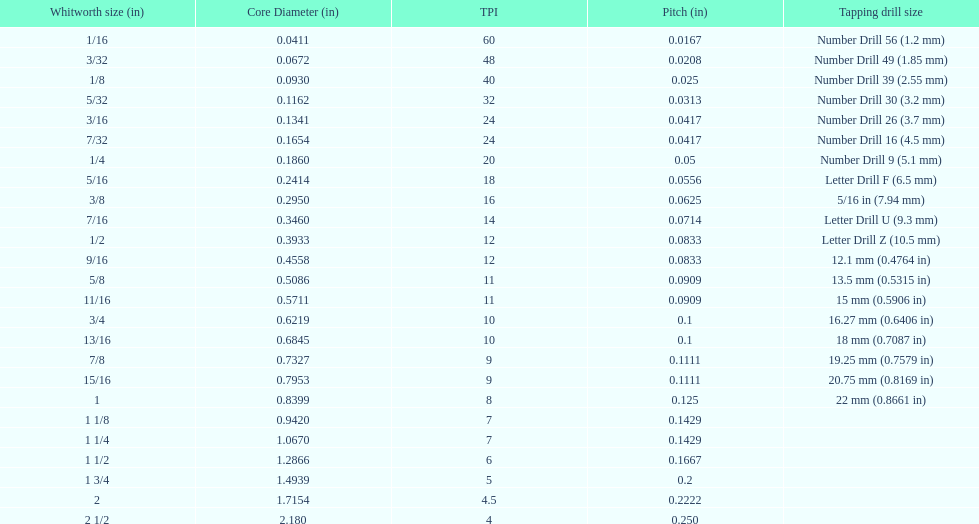Would you be able to parse every entry in this table? {'header': ['Whitworth size (in)', 'Core Diameter (in)', 'TPI', 'Pitch (in)', 'Tapping drill size'], 'rows': [['1/16', '0.0411', '60', '0.0167', 'Number Drill 56 (1.2\xa0mm)'], ['3/32', '0.0672', '48', '0.0208', 'Number Drill 49 (1.85\xa0mm)'], ['1/8', '0.0930', '40', '0.025', 'Number Drill 39 (2.55\xa0mm)'], ['5/32', '0.1162', '32', '0.0313', 'Number Drill 30 (3.2\xa0mm)'], ['3/16', '0.1341', '24', '0.0417', 'Number Drill 26 (3.7\xa0mm)'], ['7/32', '0.1654', '24', '0.0417', 'Number Drill 16 (4.5\xa0mm)'], ['1/4', '0.1860', '20', '0.05', 'Number Drill 9 (5.1\xa0mm)'], ['5/16', '0.2414', '18', '0.0556', 'Letter Drill F (6.5\xa0mm)'], ['3/8', '0.2950', '16', '0.0625', '5/16\xa0in (7.94\xa0mm)'], ['7/16', '0.3460', '14', '0.0714', 'Letter Drill U (9.3\xa0mm)'], ['1/2', '0.3933', '12', '0.0833', 'Letter Drill Z (10.5\xa0mm)'], ['9/16', '0.4558', '12', '0.0833', '12.1\xa0mm (0.4764\xa0in)'], ['5/8', '0.5086', '11', '0.0909', '13.5\xa0mm (0.5315\xa0in)'], ['11/16', '0.5711', '11', '0.0909', '15\xa0mm (0.5906\xa0in)'], ['3/4', '0.6219', '10', '0.1', '16.27\xa0mm (0.6406\xa0in)'], ['13/16', '0.6845', '10', '0.1', '18\xa0mm (0.7087\xa0in)'], ['7/8', '0.7327', '9', '0.1111', '19.25\xa0mm (0.7579\xa0in)'], ['15/16', '0.7953', '9', '0.1111', '20.75\xa0mm (0.8169\xa0in)'], ['1', '0.8399', '8', '0.125', '22\xa0mm (0.8661\xa0in)'], ['1 1/8', '0.9420', '7', '0.1429', ''], ['1 1/4', '1.0670', '7', '0.1429', ''], ['1 1/2', '1.2866', '6', '0.1667', ''], ['1 3/4', '1.4939', '5', '0.2', ''], ['2', '1.7154', '4.5', '0.2222', ''], ['2 1/2', '2.180', '4', '0.250', '']]} Does any whitworth size have the same core diameter as the number drill 26? 3/16. 